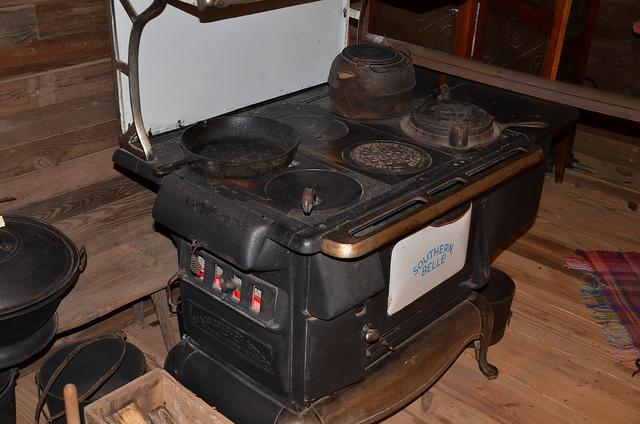What does the oven say on the side?
Write a very short answer. Southern belle. What brand is the stove?
Concise answer only. Southern belle. What is on the stove?
Write a very short answer. Tea kettle. How many burners does the stove have?
Answer briefly. 6. 